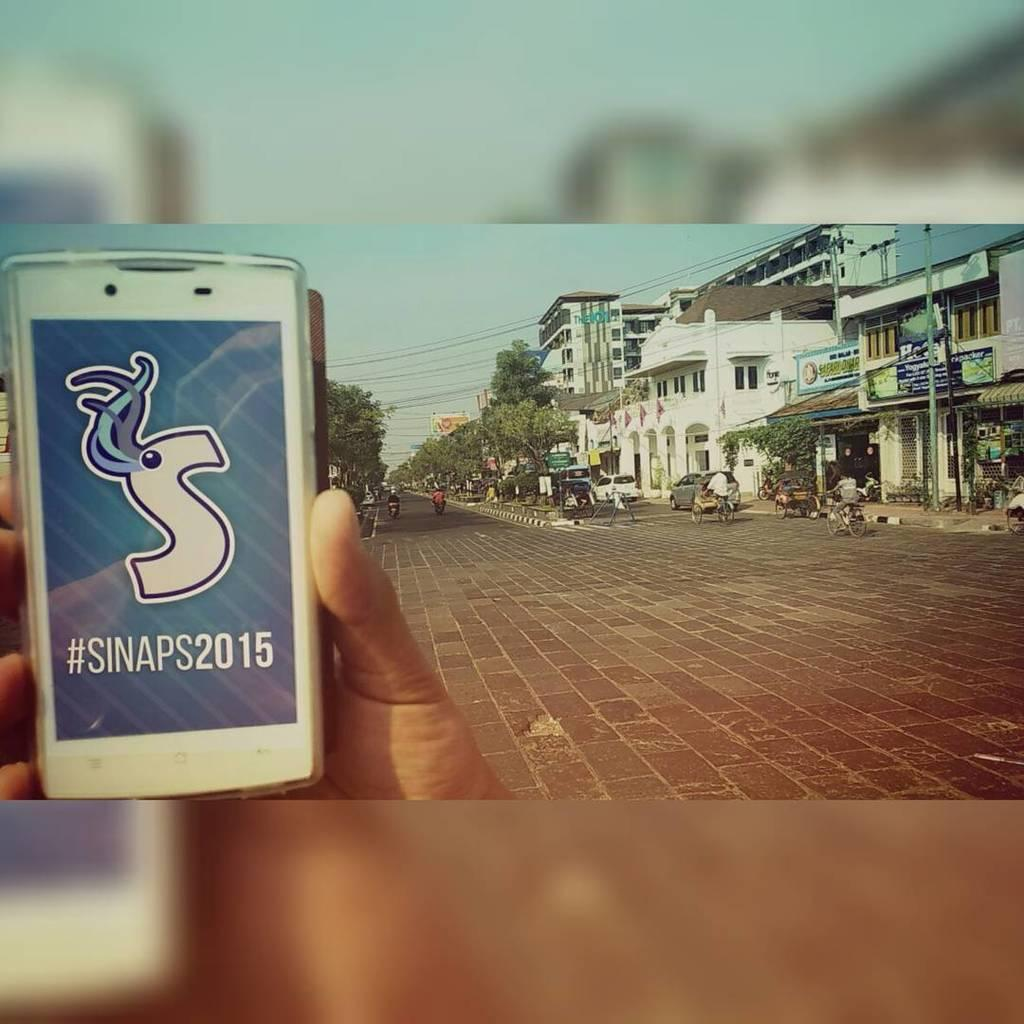<image>
Offer a succinct explanation of the picture presented. A phone with the words #SINAPS2015 is being held in front of an empty street 